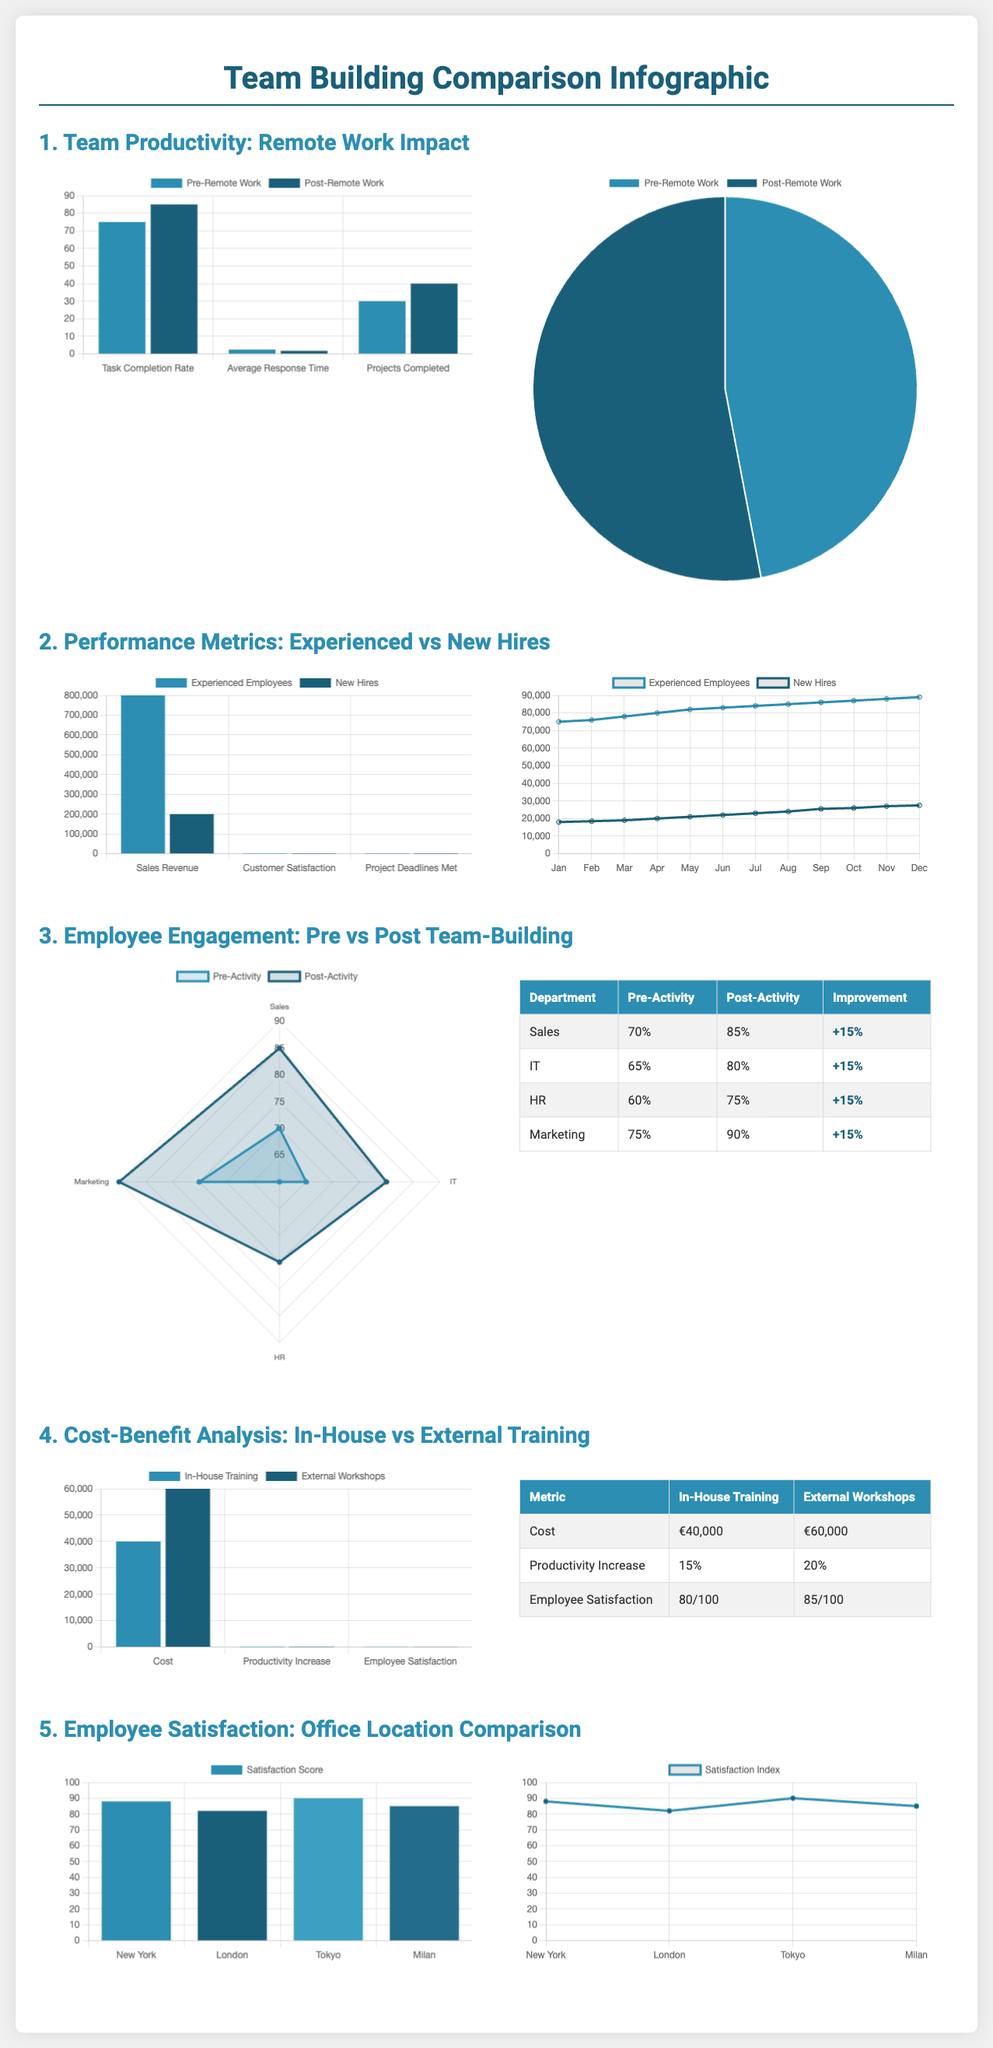What was the productivity increase in task completion rate after implementing remote work? The productivity increase in task completion rate is shown in the comparison of bar charts, where it went from 75% to 85%.
Answer: 10% What is the cost of External Workshops? The cost of External Workshops is presented in the metric table, which states that it is €60,000.
Answer: €60,000 Which department saw the highest engagement improvement after team-building activities? The table shows the improvement percentages, with Marketing having an improvement of +15%, the highest among the departments listed.
Answer: Marketing What is the percentage of employee satisfaction in Milan? The satisfaction score for Milan is found in the satisfaction charts, which shows a score of 85%.
Answer: 85% How does the productivity increase compare between In-House Training and External Workshops? The bar chart compares the productivity increase, displaying 15% for In-House Training and 20% for External Workshops.
Answer: 5% difference What was the customer satisfaction score for Experienced Employees compared to New Hires? The bar chart highlights that Experienced Employees have a customer satisfaction score of 92, while New Hires have a score of 85.
Answer: 7 points What was the average response time before remote work implementation? The bar chart includes the average response time before implementation, which was 2.5 hours.
Answer: 2.5 hours What engagement level did the IT department achieve post-activity? The table lists the post-activity engagement level for the IT department as 80%.
Answer: 80% Which location had the highest Satisfaction Index in the comparison? The satisfaction index line chart shows that Tokyo had the highest Satisfaction Index at 90%.
Answer: Tokyo 